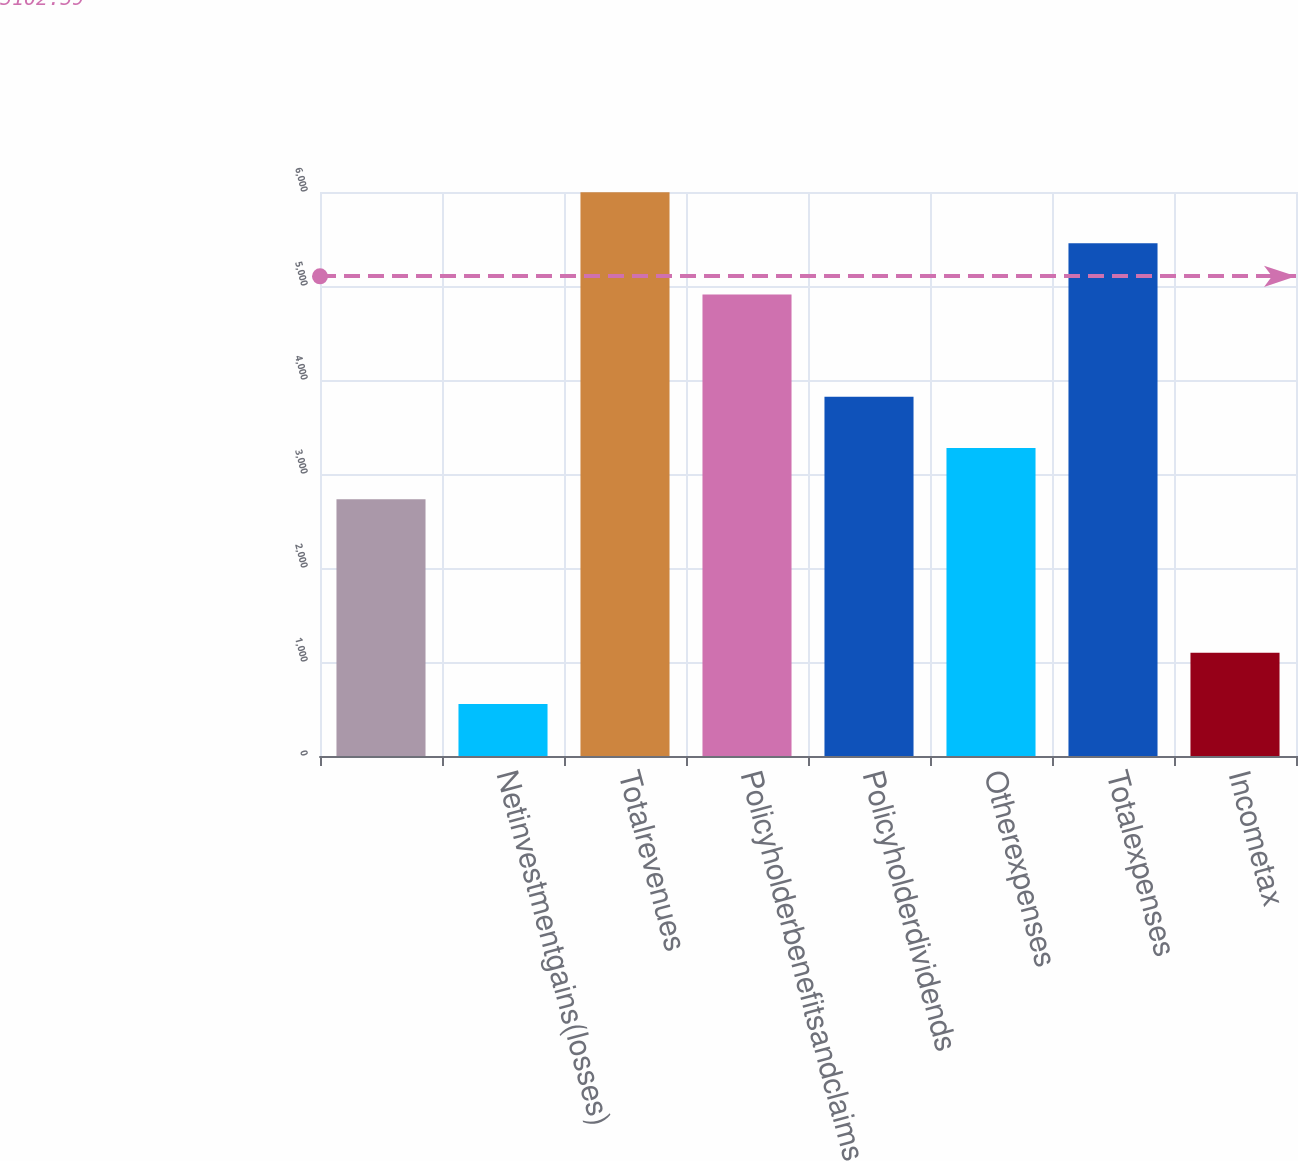Convert chart. <chart><loc_0><loc_0><loc_500><loc_500><bar_chart><ecel><fcel>Netinvestmentgains(losses)<fcel>Totalrevenues<fcel>Policyholderbenefitsandclaims<fcel>Policyholderdividends<fcel>Otherexpenses<fcel>Totalexpenses<fcel>Incometax<nl><fcel>2731.5<fcel>553.5<fcel>5998.5<fcel>4909.5<fcel>3820.5<fcel>3276<fcel>5454<fcel>1098<nl></chart> 